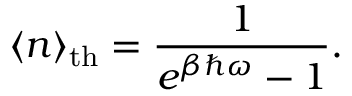<formula> <loc_0><loc_0><loc_500><loc_500>\langle n \rangle _ { t h } = { \frac { 1 } { e ^ { \beta \hbar { \omega } } - 1 } } .</formula> 